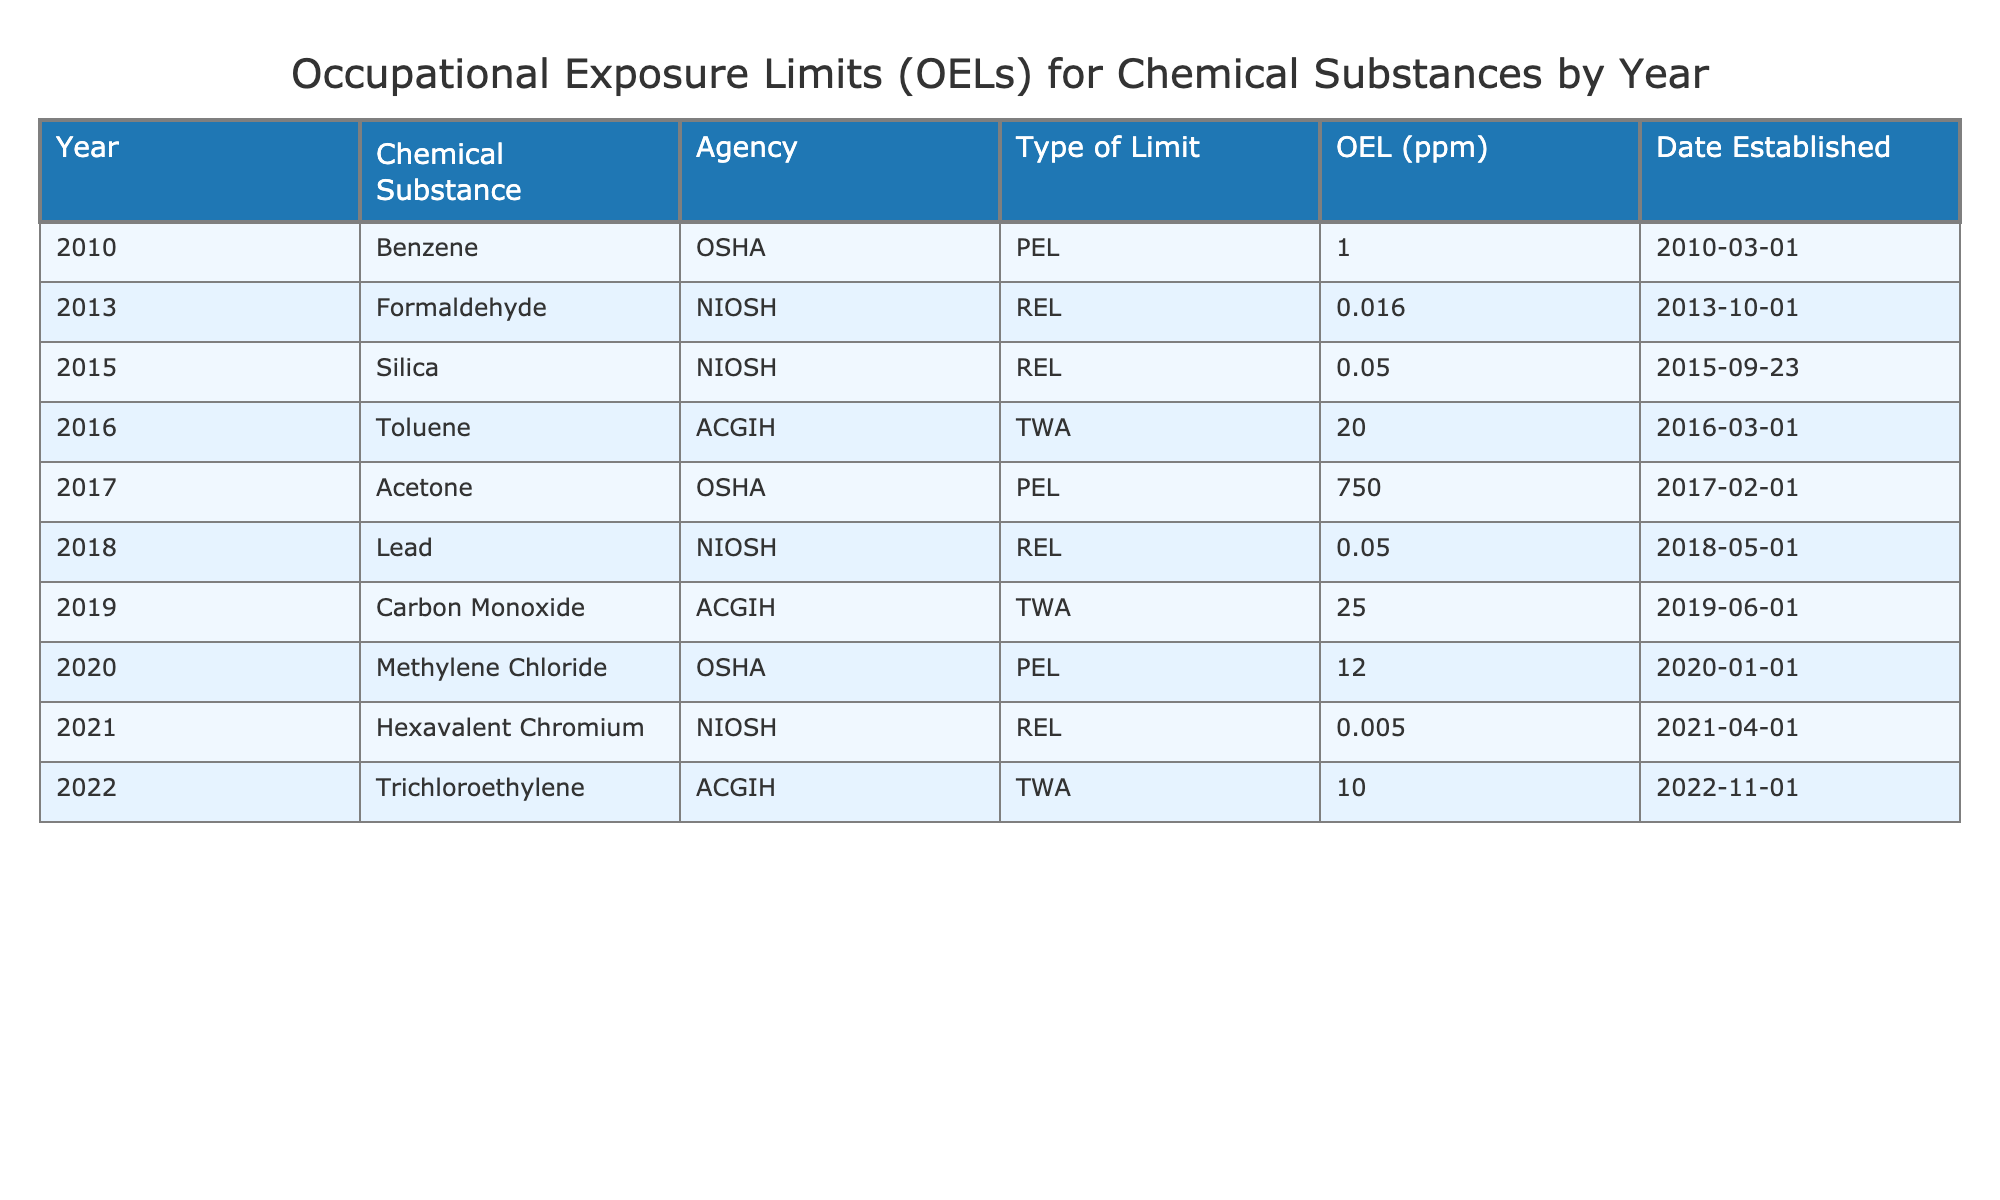What is the OEL for Benzene established by OSHA? In the table, we can find Benzene listed under the year 2010 with an Agency of OSHA. The corresponding OEL (ppm) value is mentioned next to it, which is 1. Therefore, the answer can be directly retrieved.
Answer: 1 Which chemical substance has the lowest OEL and what is that value? By examining the table, we can see that Hexavalent Chromium has an OEL of 0.005 ppm, which is the lowest value listed. A quick comparison of all the OEL values confirms this finding.
Answer: 0.005 What was the OEL established for Formaldehyde by NIOSH in 2013? The table indicates that in 2013, NIOSH set an OEL for Formaldehyde at 0.016 ppm. This information is directly present in the table.
Answer: 0.016 Is there a Chemical Substance with an OEL of 0.05 ppm in the year 2018? Upon checking the table, we see that Lead has an OEL of 0.05 ppm, and it was established in the year 2018 by NIOSH. Therefore, the statement is true.
Answer: Yes What is the average OEL value for chemical substances established by OSHA? From the table, the OELs established by OSHA are 1 (Benzene), 750 (Acetone), and 12 (Methylene Chloride). To find the average, we sum these values: 1 + 750 + 12 = 763. Then, we divide by the number of entries (3) to find the average: 763 / 3 = 254.33.
Answer: 254.33 Which year saw the establishment of an OEL for both Toluene and Trichloroethylene, and what were their values? Toluene was established in 2016 with an OEL of 20 ppm while Trichloroethylene was established in 2022 with an OEL of 10 ppm. Thus, the years differ, and the chemicals were not established in the same year.
Answer: 2016 and 2022; 20 ppm and 10 ppm Did NIOSH establish an OEL for Silica in 2015? Silica does appear in the table for the year 2015, and the agency responsible is NIOSH, which confirms the statement as true.
Answer: Yes What is the OEL for Acetone compared to the OEL for Carbon Monoxide? Acetone has an OEL of 750 ppm, while Carbon Monoxide has an OEL of 25 ppm. Comparing these values directly shows that Acetone's OEL is significantly higher.
Answer: 750 ppm vs. 25 ppm 